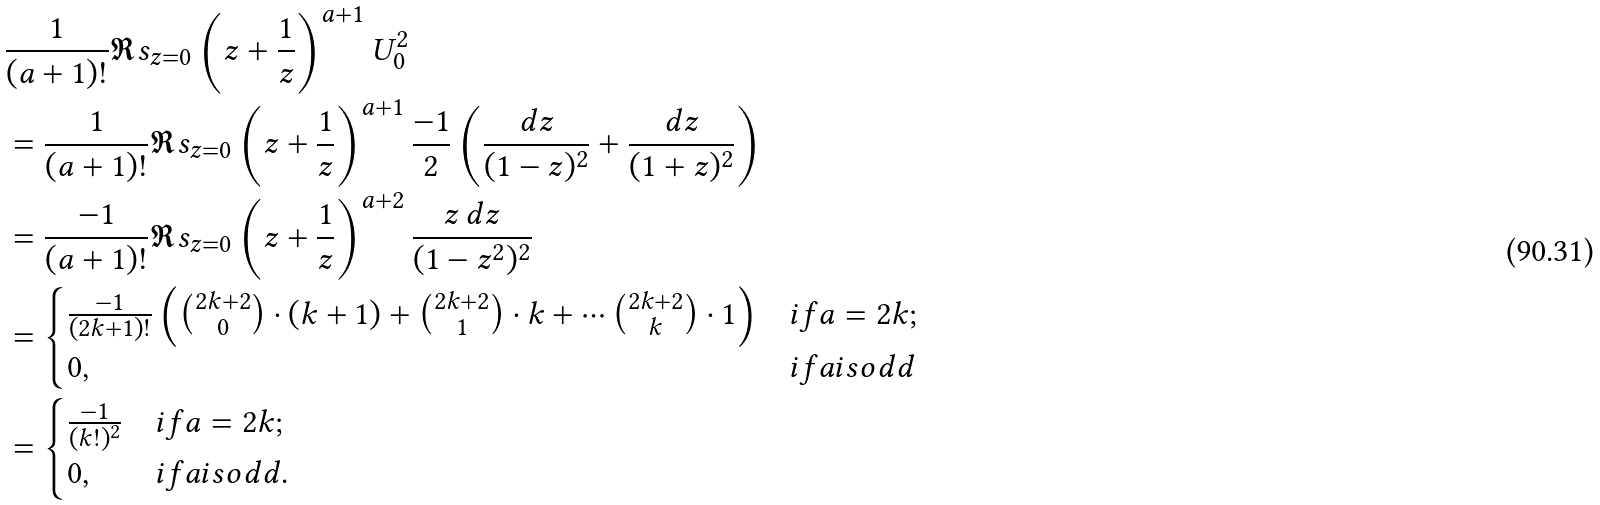Convert formula to latex. <formula><loc_0><loc_0><loc_500><loc_500>& \frac { 1 } { ( a + 1 ) ! } \Re s _ { z = 0 } \left ( z + \frac { 1 } { z } \right ) ^ { a + 1 } U ^ { 2 } _ { 0 } \\ & = \frac { 1 } { ( a + 1 ) ! } \Re s _ { z = 0 } \left ( z + \frac { 1 } { z } \right ) ^ { a + 1 } \frac { - 1 } { 2 } \left ( \frac { d z } { ( 1 - z ) ^ { 2 } } + \frac { d z } { ( 1 + z ) ^ { 2 } } \right ) \\ & = \frac { - 1 } { ( a + 1 ) ! } \Re s _ { z = 0 } \left ( z + \frac { 1 } { z } \right ) ^ { a + 2 } \frac { z \, d z } { ( 1 - z ^ { 2 } ) ^ { 2 } } \\ & = \begin{cases} \frac { - 1 } { ( 2 k + 1 ) ! } \left ( \binom { 2 k + 2 } { 0 } \cdot ( k + 1 ) + \binom { 2 k + 2 } { 1 } \cdot k + \cdots \binom { 2 k + 2 } { k } \cdot 1 \right ) & i f a = 2 k ; \\ 0 , & i f a i s o d d \end{cases} \\ & = \begin{cases} \frac { - 1 } { ( k ! ) ^ { 2 } } & i f a = 2 k ; \\ 0 , & i f a i s o d d . \end{cases}</formula> 